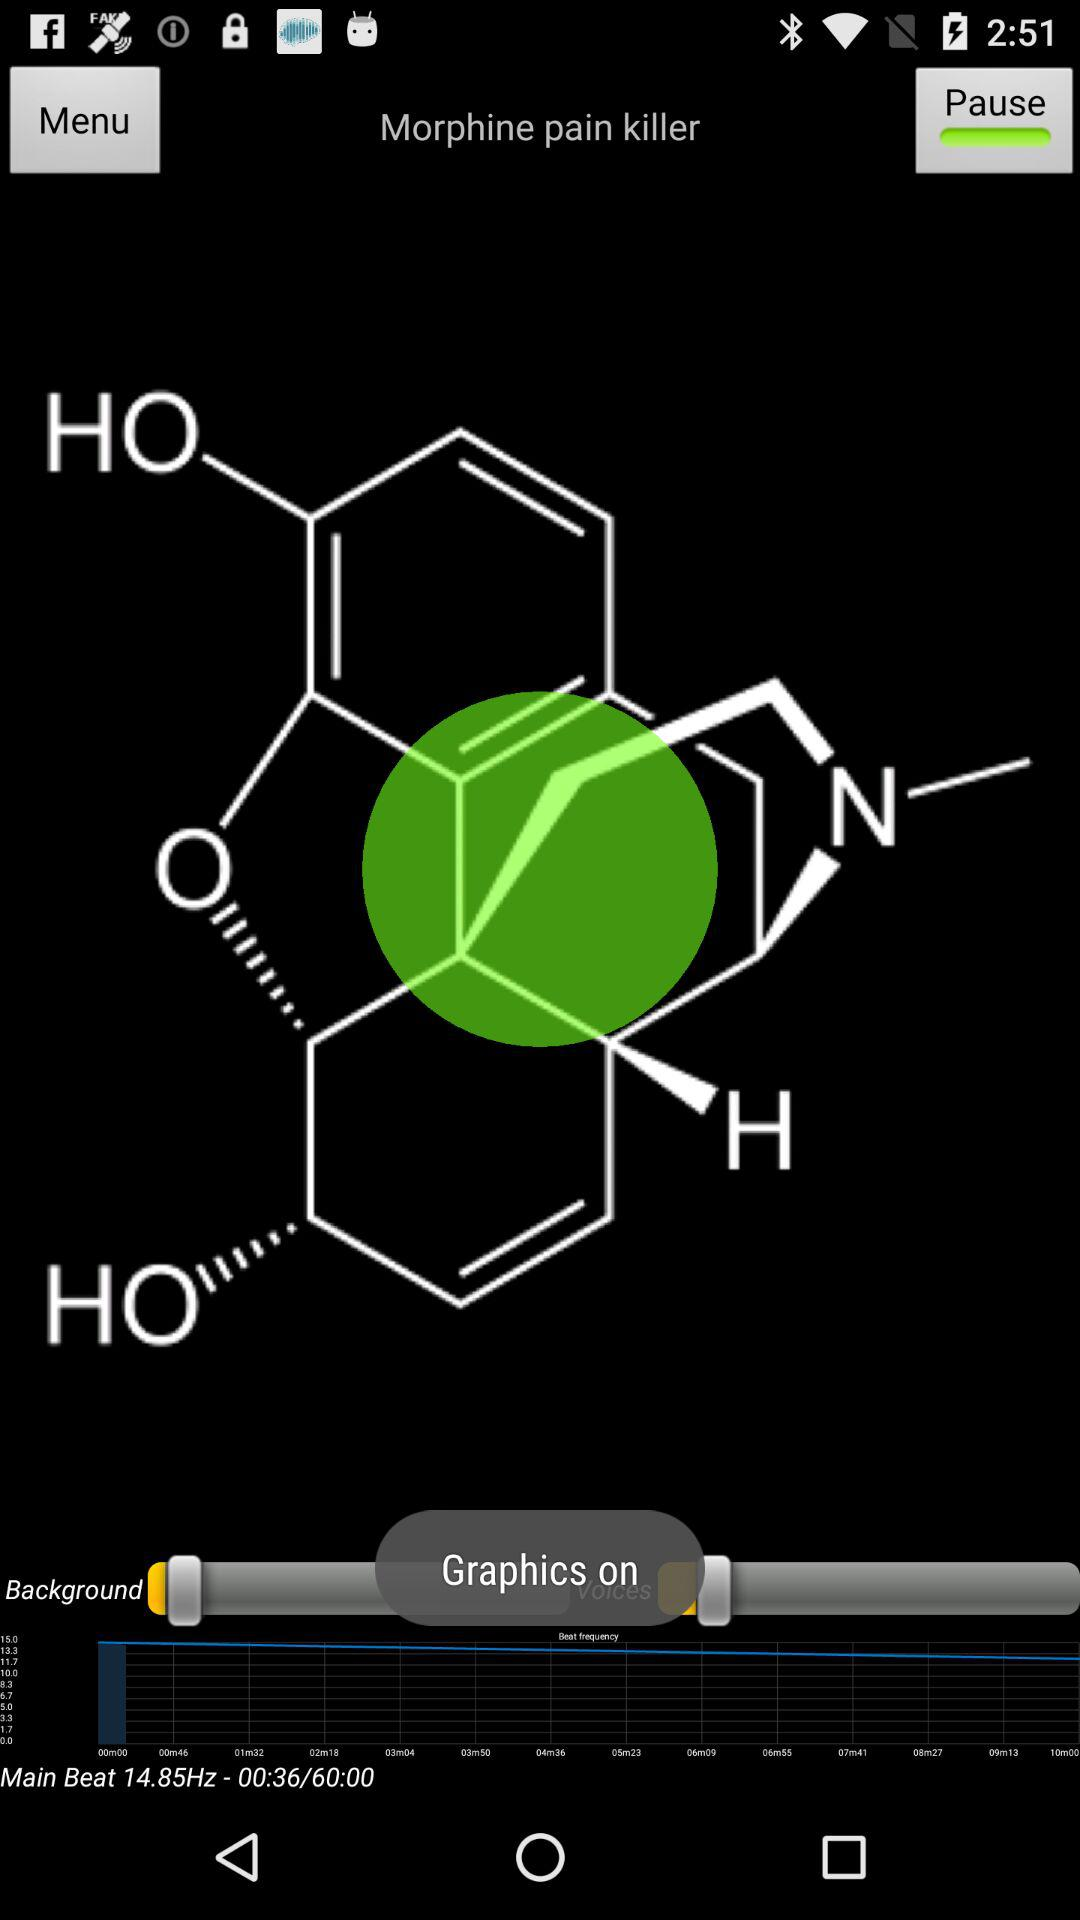What is the main beat frequency? The main beat frequency is 14.85Hz. 